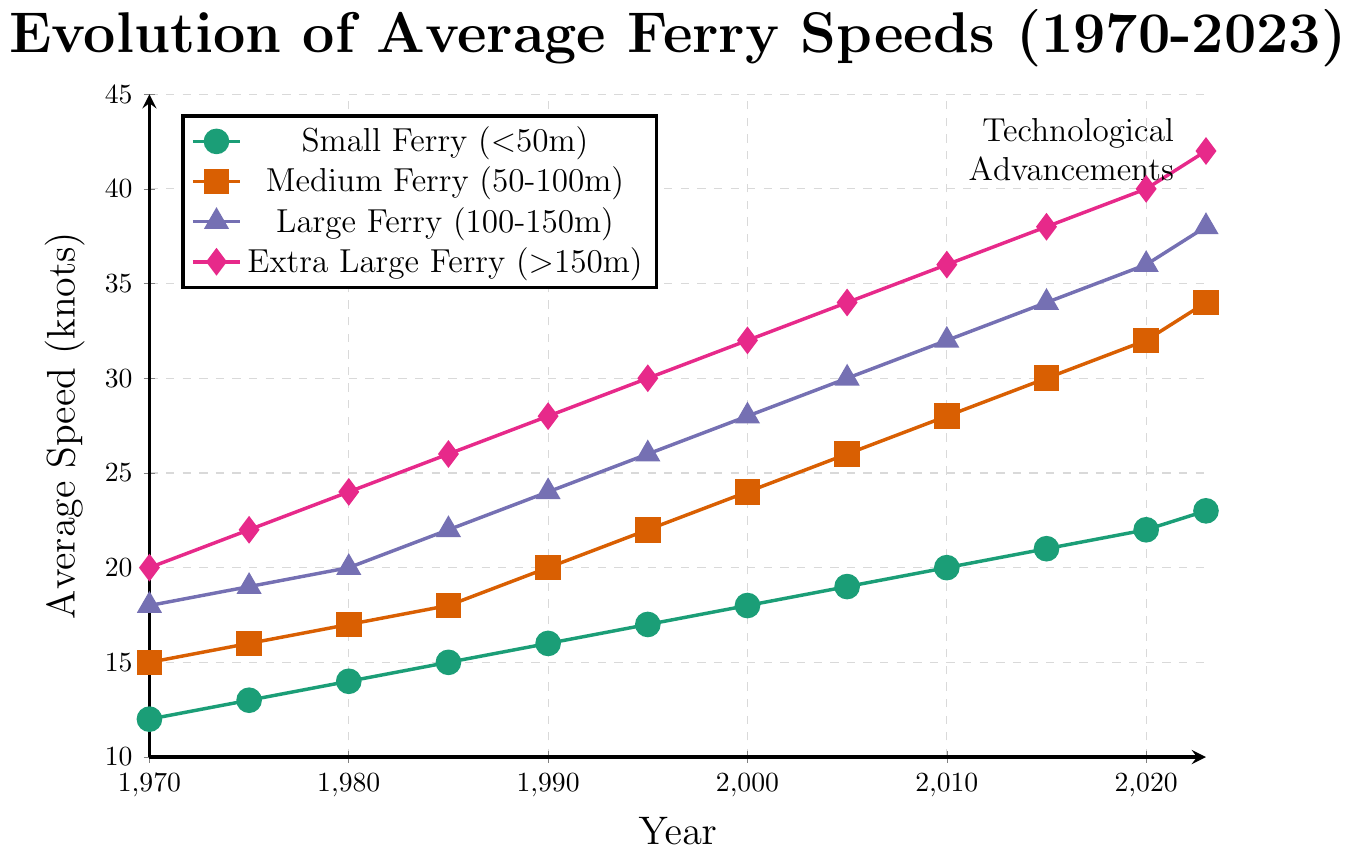What's the average speed of a medium ferry in 2023 and 2000? To find the average speed, sum the values of the speeds in 2023 and 2000 and then divide by 2. According to the data, the speeds are 34 knots in 2023 and 24 knots in 2000. So, (34 + 24) / 2 = 29.
Answer: 29 Which type of ferry had the highest increase in average speed from 1970 to 2023? Calculate the difference in average speeds between 2023 and 1970 for each ferry type. Small Ferry: 23 - 12 = 11, Medium Ferry: 34 - 15 = 19, Large Ferry: 38 - 18 = 20, Extra Large Ferry: 42 - 20 = 22. Extra Large Ferry shows the greatest increase.
Answer: Extra Large Ferry In which decade did the average speed of small ferries reach 18 knots? Check the 'Small Ferry' line data to find when the speed first reaches 18 knots. It shows 18 knots in the year 2000.
Answer: 2000 How much faster is the average speed of a large ferry compared to a small ferry in 2023? In 2023, a large ferry has a speed of 38 knots, and a small ferry has a speed of 23 knots. The difference is 38 - 23 = 15 knots.
Answer: 15 What's the average increase in speed per decade for medium ferries from 1970 to 2023? Calculate the total increase in speed from 1970 (15 knots) to 2023 (34 knots), which is 34 - 15 = 19 knots. Then, divide by the number of decades (approximately 5 decades), so 19 / 5 = 3.8 knots per decade.
Answer: 3.8 Which ferry size type shows the most consistent increase in speed over the years? Evaluate the differences in speed increments for each ferry type across each time period and compare the consistency. All types show steady increases, but small ferries increase by 1 knot every 5 years consistently.
Answer: Small Ferry What visual attributes represent extra-large ferries in the plot? Refer to the legend and lines in the figure. Extra Large Ferry is represented by a magenta line with diamond markers.
Answer: magenta line, diamond markers Between which years did the large ferry speeds surpass 30 knots? Check the years in the Large Ferry data where the speed first surpasses 30 knots. The large ferry speed surpassed 30 knots between 2005 (30 knots) and 2010 (32 knots).
Answer: Between 2005 and 2010 How many different times was the average speed of the small ferry recorded to increase up till 2023? Identify and count the speed increments for small ferries from 1970 (12 knots) to 2023 (23 knots). The speed increases occurred 11 times.
Answer: 11 What is the trend line showing the technological advancements represented in the chart? Observe the overall increase in average speeds across all ferry sizes from 1970 to 2023. The trend line illustrates a general increase in average speeds over time, reflecting technological advancements.
Answer: Increasing trend 